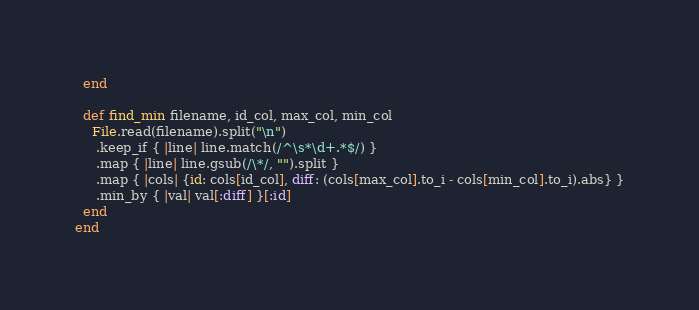Convert code to text. <code><loc_0><loc_0><loc_500><loc_500><_Ruby_>  end

  def find_min filename, id_col, max_col, min_col
    File.read(filename).split("\n")
     .keep_if { |line| line.match(/^\s*\d+.*$/) }
     .map { |line| line.gsub(/\*/, "").split }
     .map { |cols| {id: cols[id_col], diff: (cols[max_col].to_i - cols[min_col].to_i).abs} }
     .min_by { |val| val[:diff] }[:id]
  end
end</code> 